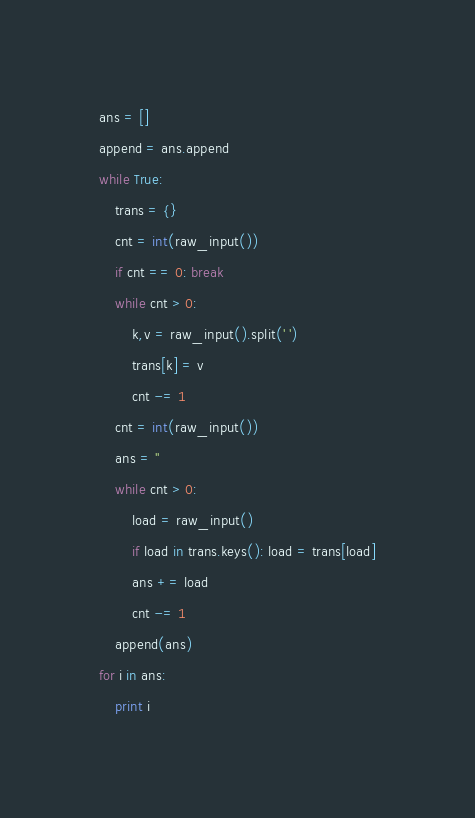Convert code to text. <code><loc_0><loc_0><loc_500><loc_500><_Python_>ans = []
append = ans.append
while True:
    trans = {}
    cnt = int(raw_input())
    if cnt == 0: break
    while cnt > 0:
        k,v = raw_input().split(' ')
        trans[k] = v
        cnt -= 1
    cnt = int(raw_input())
    ans = ''
    while cnt > 0:
        load = raw_input()
        if load in trans.keys(): load = trans[load]
        ans += load
        cnt -= 1
    append(ans)
for i in ans:
    print i</code> 